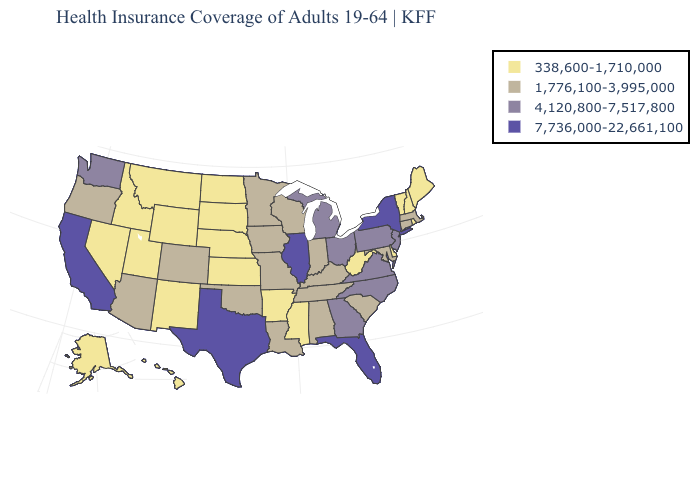What is the value of Maryland?
Short answer required. 1,776,100-3,995,000. Name the states that have a value in the range 4,120,800-7,517,800?
Be succinct. Georgia, Michigan, New Jersey, North Carolina, Ohio, Pennsylvania, Virginia, Washington. Does the first symbol in the legend represent the smallest category?
Quick response, please. Yes. Name the states that have a value in the range 4,120,800-7,517,800?
Answer briefly. Georgia, Michigan, New Jersey, North Carolina, Ohio, Pennsylvania, Virginia, Washington. What is the highest value in states that border Rhode Island?
Quick response, please. 1,776,100-3,995,000. Among the states that border Indiana , which have the highest value?
Short answer required. Illinois. What is the lowest value in the MidWest?
Be succinct. 338,600-1,710,000. What is the highest value in the USA?
Quick response, please. 7,736,000-22,661,100. Does Missouri have a lower value than Ohio?
Concise answer only. Yes. Does the first symbol in the legend represent the smallest category?
Answer briefly. Yes. Which states have the highest value in the USA?
Concise answer only. California, Florida, Illinois, New York, Texas. What is the value of New Mexico?
Write a very short answer. 338,600-1,710,000. What is the value of Maine?
Keep it brief. 338,600-1,710,000. Name the states that have a value in the range 7,736,000-22,661,100?
Short answer required. California, Florida, Illinois, New York, Texas. What is the value of Kentucky?
Concise answer only. 1,776,100-3,995,000. 